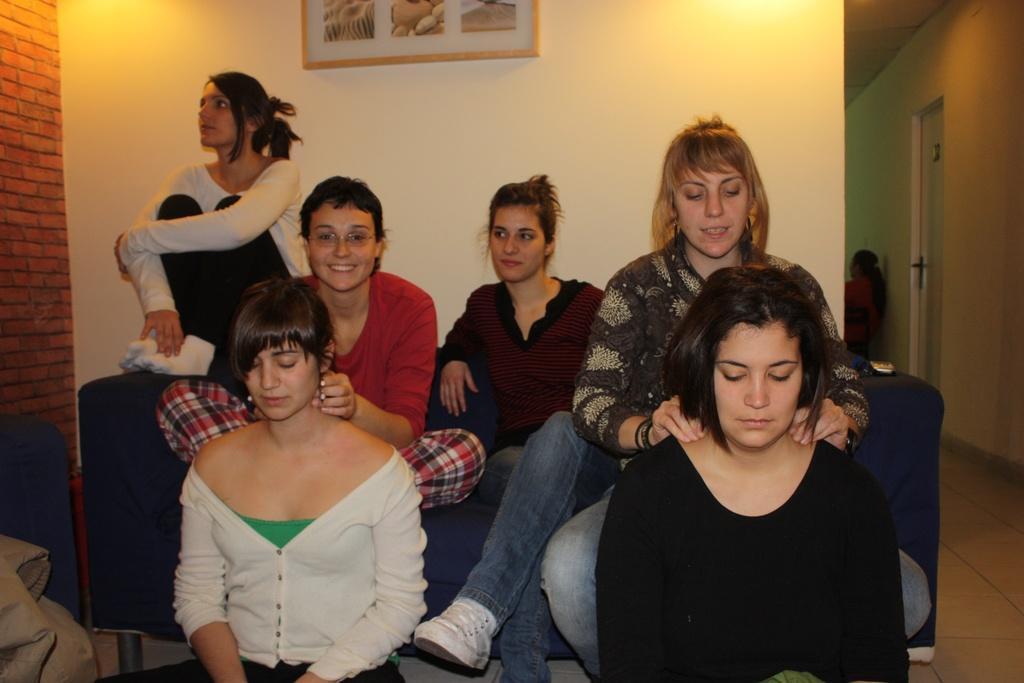How would you summarize this image in a sentence or two? In this image I can see the group of people with different color dresses. I can see few people are sitting on the couch. In the background I can see the frame to the wall. To the right I can see the door and another person. 